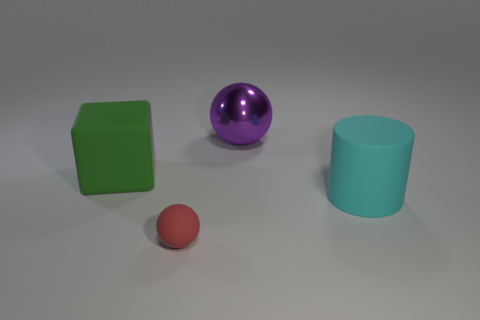There is a purple thing; what shape is it?
Ensure brevity in your answer.  Sphere. There is a matte thing that is to the left of the cyan matte object and behind the tiny red matte ball; what color is it?
Provide a short and direct response. Green. What is the material of the green thing?
Give a very brief answer. Rubber. The matte thing that is to the left of the tiny red rubber object has what shape?
Provide a succinct answer. Cube. There is a shiny sphere that is the same size as the green cube; what is its color?
Your answer should be very brief. Purple. Does the sphere that is on the left side of the purple ball have the same material as the large cylinder?
Offer a very short reply. Yes. What size is the rubber thing that is on the right side of the large green rubber thing and to the left of the cylinder?
Give a very brief answer. Small. There is a thing behind the green rubber object; how big is it?
Provide a short and direct response. Large. What is the shape of the matte thing right of the sphere in front of the object that is on the right side of the large purple thing?
Give a very brief answer. Cylinder. How many other objects are there of the same shape as the large green thing?
Provide a succinct answer. 0. 